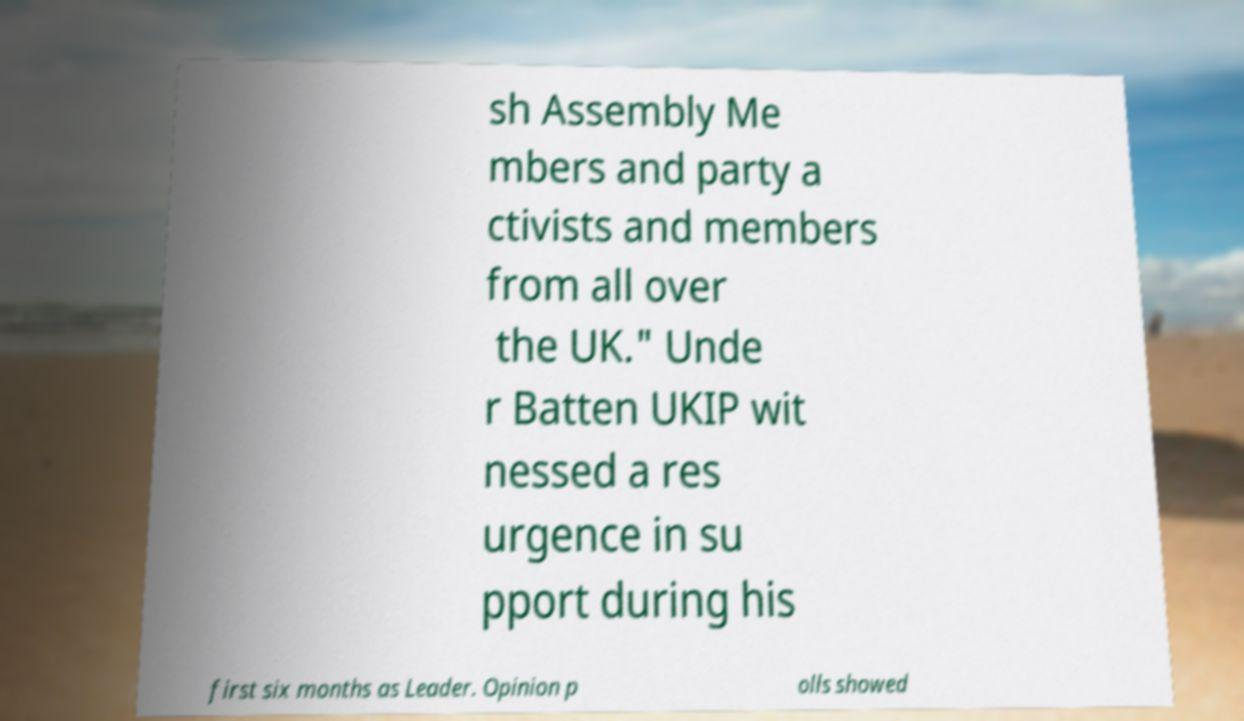Could you assist in decoding the text presented in this image and type it out clearly? sh Assembly Me mbers and party a ctivists and members from all over the UK." Unde r Batten UKIP wit nessed a res urgence in su pport during his first six months as Leader. Opinion p olls showed 